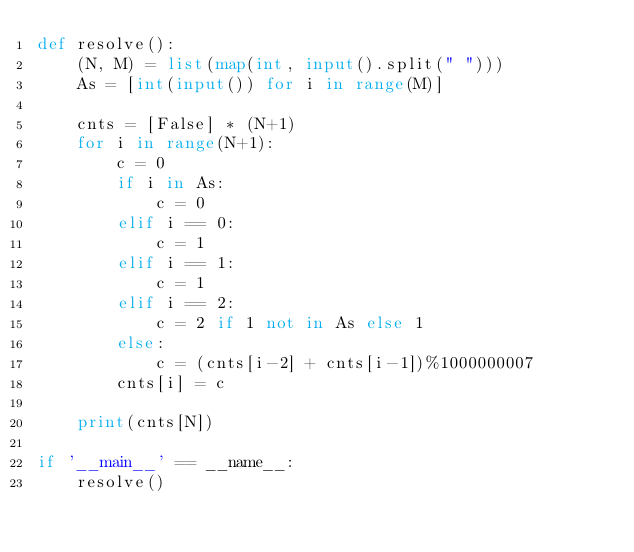<code> <loc_0><loc_0><loc_500><loc_500><_Python_>def resolve():
    (N, M) = list(map(int, input().split(" ")))
    As = [int(input()) for i in range(M)]

    cnts = [False] * (N+1)
    for i in range(N+1):
        c = 0
        if i in As:
            c = 0
        elif i == 0:
            c = 1
        elif i == 1:
            c = 1
        elif i == 2:
            c = 2 if 1 not in As else 1
        else:
            c = (cnts[i-2] + cnts[i-1])%1000000007
        cnts[i] = c

    print(cnts[N])

if '__main__' == __name__:
    resolve()</code> 